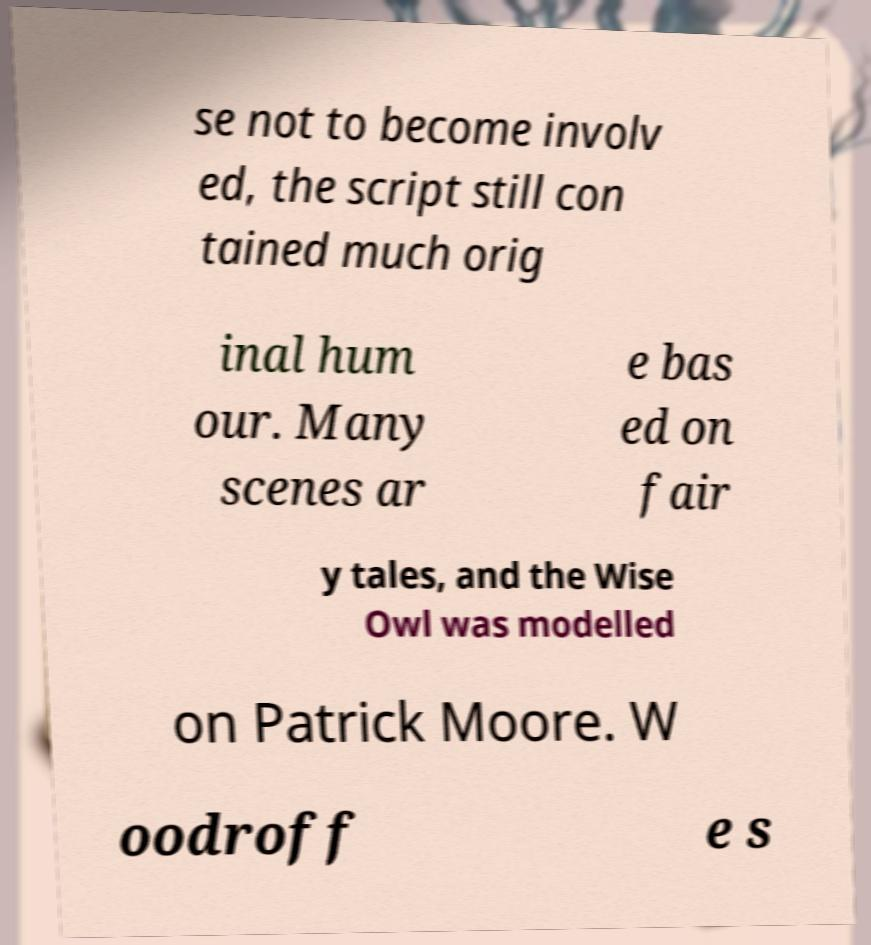There's text embedded in this image that I need extracted. Can you transcribe it verbatim? se not to become involv ed, the script still con tained much orig inal hum our. Many scenes ar e bas ed on fair y tales, and the Wise Owl was modelled on Patrick Moore. W oodroff e s 